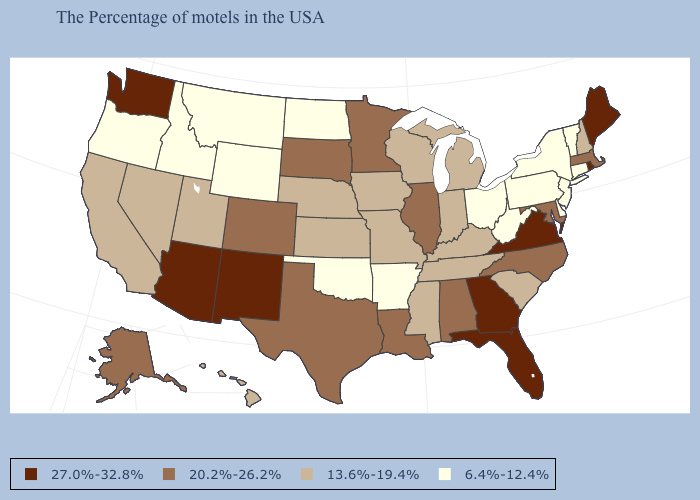Does Maine have the highest value in the USA?
Quick response, please. Yes. Among the states that border New Mexico , does Oklahoma have the lowest value?
Be succinct. Yes. What is the value of Tennessee?
Short answer required. 13.6%-19.4%. What is the highest value in the Northeast ?
Be succinct. 27.0%-32.8%. What is the value of New Jersey?
Answer briefly. 6.4%-12.4%. Does Louisiana have a higher value than Alaska?
Give a very brief answer. No. What is the lowest value in the USA?
Concise answer only. 6.4%-12.4%. Name the states that have a value in the range 20.2%-26.2%?
Keep it brief. Massachusetts, Maryland, North Carolina, Alabama, Illinois, Louisiana, Minnesota, Texas, South Dakota, Colorado, Alaska. What is the value of Iowa?
Be succinct. 13.6%-19.4%. What is the value of Virginia?
Concise answer only. 27.0%-32.8%. Among the states that border Vermont , which have the highest value?
Concise answer only. Massachusetts. What is the value of Rhode Island?
Give a very brief answer. 27.0%-32.8%. What is the lowest value in the Northeast?
Short answer required. 6.4%-12.4%. Does Connecticut have the highest value in the Northeast?
Short answer required. No. Does Wisconsin have the highest value in the USA?
Be succinct. No. 